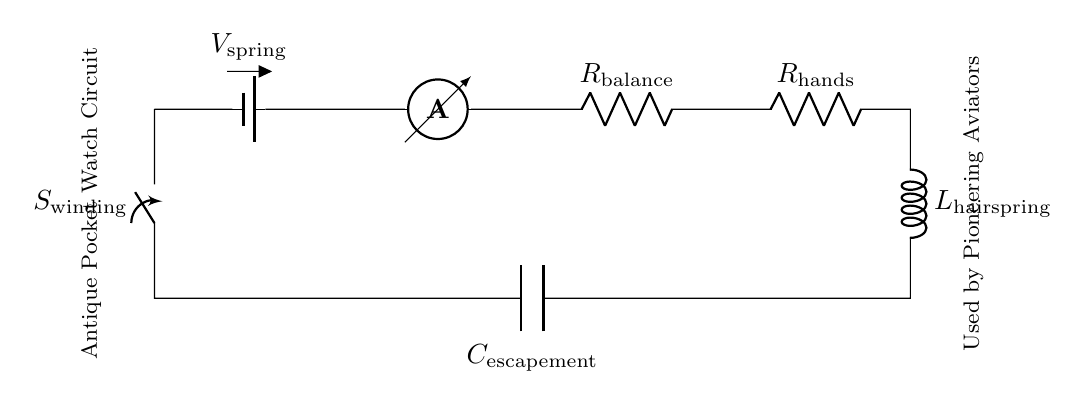What is the first component in the circuit? The first component in the circuit is a battery, which provides the voltage needed to power the watch. The diagram indicates it as the starting point of the current flow.
Answer: Battery What is the purpose of the ammeter in this circuit? The ammeter measures the current flowing through the circuit. Its placement allows it to directly monitor the electrical flow from the battery to the other components, ensuring the watch operates correctly.
Answer: Current measurement What is the total resistance in the circuit? To find the total resistance, sum the resistances of \( R_\text{balance} \) and \( R_\text{hands} \). Since the components are in series, the total resistance is the sum of individual resistances.
Answer: R balance + R hands What is the role of the hairspring in the circuit? The hairspring serves as an inductor, which helps regulate the release of energy in the electronic circuit, controlling the timing mechanism necessary for the watch to function accurately.
Answer: Inductor Which component is used to wind the watch? The component used for winding is the switch labeled \( S_\text{winding} \). It connects or disconnects the circuit to wind the mechanism, allowing for energy storage in the watch.
Answer: Switch What would happen if the circuit is open? If the circuit is open, current cannot flow, and the watch will stop functioning; it will not display time due to a lack of continuous electrical supply from the battery to the components.
Answer: Stops functioning How are the components connected in this watch circuit? All components are connected in a series configuration, meaning the current passes through each component sequentially. This defines the path that the electrical current follows within the circuit.
Answer: Series connection 